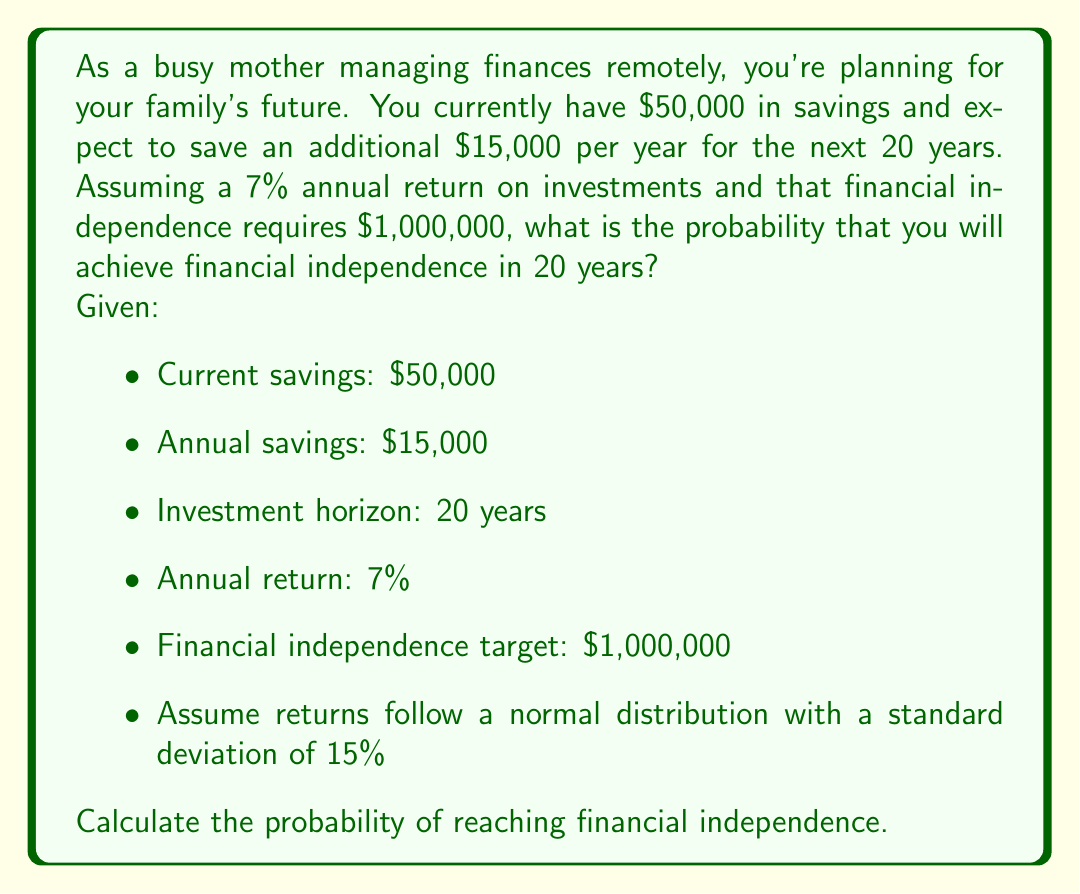Teach me how to tackle this problem. To solve this problem, we'll follow these steps:

1. Calculate the expected future value of savings
2. Determine the mean and standard deviation of the log-normal distribution
3. Calculate the z-score
4. Find the probability using the standard normal distribution

Step 1: Calculate the expected future value of savings

We can use the future value formula for a growing annuity:

$$ FV = P(1+r)^n + A\frac{(1+r)^n - 1}{r} $$

Where:
$FV$ = Future Value
$P$ = Present Value (current savings)
$A$ = Annual contribution
$r$ = Annual return
$n$ = Number of years

Plugging in our values:

$$ FV = 50000(1.07)^{20} + 15000\frac{(1.07)^{20} - 1}{0.07} $$

$$ FV = 50000(3.8697) + 15000(41.002) $$

$$ FV = 193,485 + 615,030 = 808,515 $$

Step 2: Determine the mean and standard deviation of the log-normal distribution

The expected log return ($\mu$) and volatility ($\sigma$) are:

$$ \mu = \ln(1 + 0.07) = 0.0677 $$
$$ \sigma = 0.15 $$

The mean ($m$) and standard deviation ($s$) of the log-normal distribution are:

$$ m = \ln(808515) + 20(\mu - \frac{\sigma^2}{2}) = 13.8067 $$
$$ s = \sqrt{20}\sigma = 0.6708 $$

Step 3: Calculate the z-score

The z-score for reaching $1,000,000 is:

$$ z = \frac{\ln(1000000) - m}{s} = \frac{13.8155 - 13.8067}{0.6708} = 0.0131 $$

Step 4: Find the probability using the standard normal distribution

The probability of reaching financial independence is:

$$ P(X > 1000000) = 1 - \Phi(z) $$

Where $\Phi(z)$ is the cumulative distribution function of the standard normal distribution.

Using a standard normal table or calculator, we find:

$$ 1 - \Phi(0.0131) = 0.4948 $$
Answer: The probability of achieving financial independence in 20 years is approximately 49.48%. 